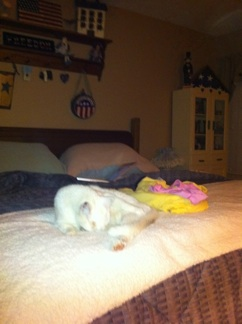Can you describe the surroundings? Certainly! The cat is on a neatly made bed with a brown blanket. There's a soft-looking yellow and pink item next to it, which may be a toy or cushion. The room has a cozy feel with various decorations on the wall and shelves, including patriotic elements and wooden furniture. 